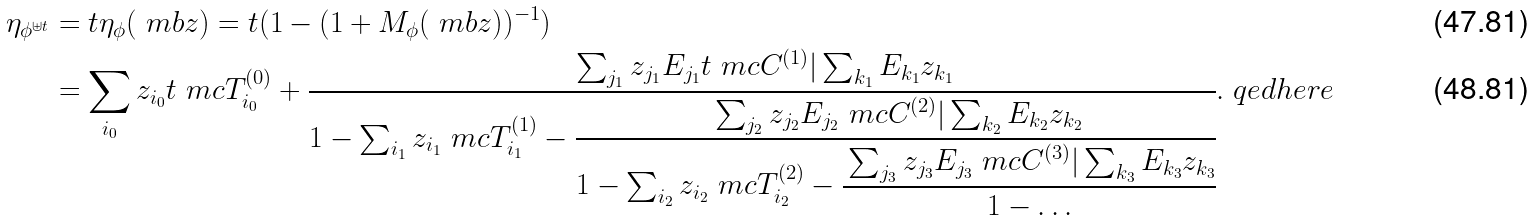Convert formula to latex. <formula><loc_0><loc_0><loc_500><loc_500>\eta _ { \phi ^ { \uplus t } } & = t \eta _ { \phi } ( \ m b { z } ) = t ( 1 - ( 1 + M _ { \phi } ( \ m b { z } ) ) ^ { - 1 } ) \\ & = \sum _ { i _ { 0 } } z _ { i _ { 0 } } t \ m c { T } _ { i _ { 0 } } ^ { ( 0 ) } + \cfrac { \sum _ { j _ { 1 } } z _ { j _ { 1 } } E _ { j _ { 1 } } t \ m c { C } ^ { ( 1 ) } | \sum _ { k _ { 1 } } E _ { k _ { 1 } } z _ { k _ { 1 } } } { 1 - \sum _ { i _ { 1 } } z _ { i _ { 1 } } \ m c { T } _ { i _ { 1 } } ^ { ( 1 ) } - \cfrac { \sum _ { j _ { 2 } } z _ { j _ { 2 } } E _ { j _ { 2 } } \ m c { C } ^ { ( 2 ) } | \sum _ { k _ { 2 } } E _ { k _ { 2 } } z _ { k _ { 2 } } } { 1 - \sum _ { i _ { 2 } } z _ { i _ { 2 } } \ m c { T } _ { i _ { 2 } } ^ { ( 2 ) } - \cfrac { \sum _ { j _ { 3 } } z _ { j _ { 3 } } E _ { j _ { 3 } } \ m c { C } ^ { ( 3 ) } | \sum _ { k _ { 3 } } E _ { k _ { 3 } } z _ { k _ { 3 } } } { 1 - \dots } } } . \ q e d h e r e</formula> 